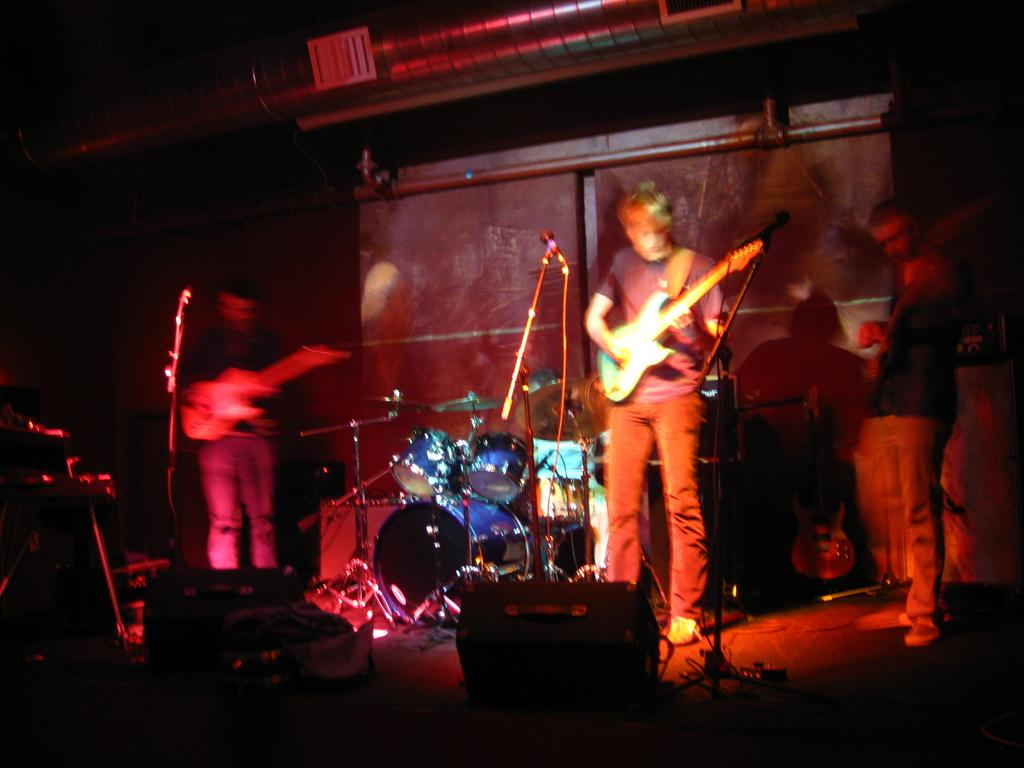How many people are present in the image? There are three persons standing in the image. What are two of the persons holding? Two of the persons are holding a guitar. What object is used for amplifying sound in the image? There is a microphone in the image. What is used to hold the microphone in place? There is a mic holder in the image. What are the objects held by the persons in the image used for? These are musical instruments, which are used for making music. What type of hammer is being used to select a throne in the image? There is no hammer or throne present in the image. 